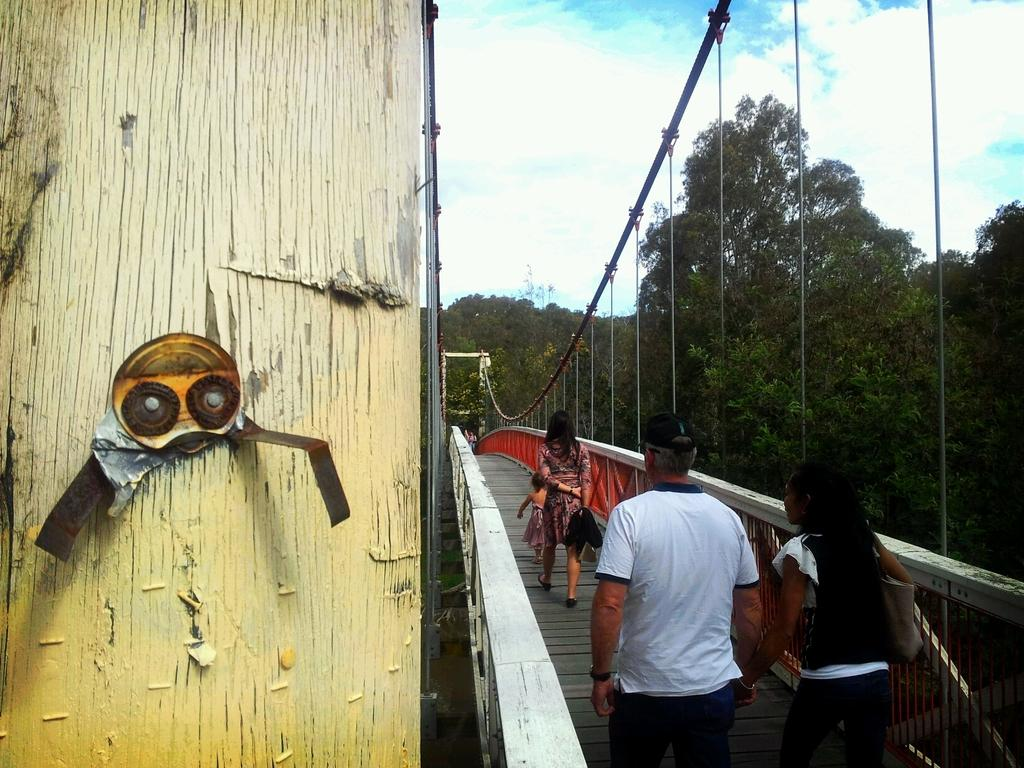What structure is located on the right side of the image? There is a bridge on the right side of the image. What are the people in the image doing? People are walking on the bridge. What can be seen on the left side of the image? There is a wall on the left side of the image. What type of vegetation is visible in the background of the image? There are trees in the background of the image. What is visible in the background of the image besides the trees? The sky is visible in the background of the image. What type of music can be heard playing from the education center in the image? There is no education center or music present in the image. What type of amusement can be seen on the bridge in the image? There is no amusement present on the bridge in the image; people are simply walking on it. 